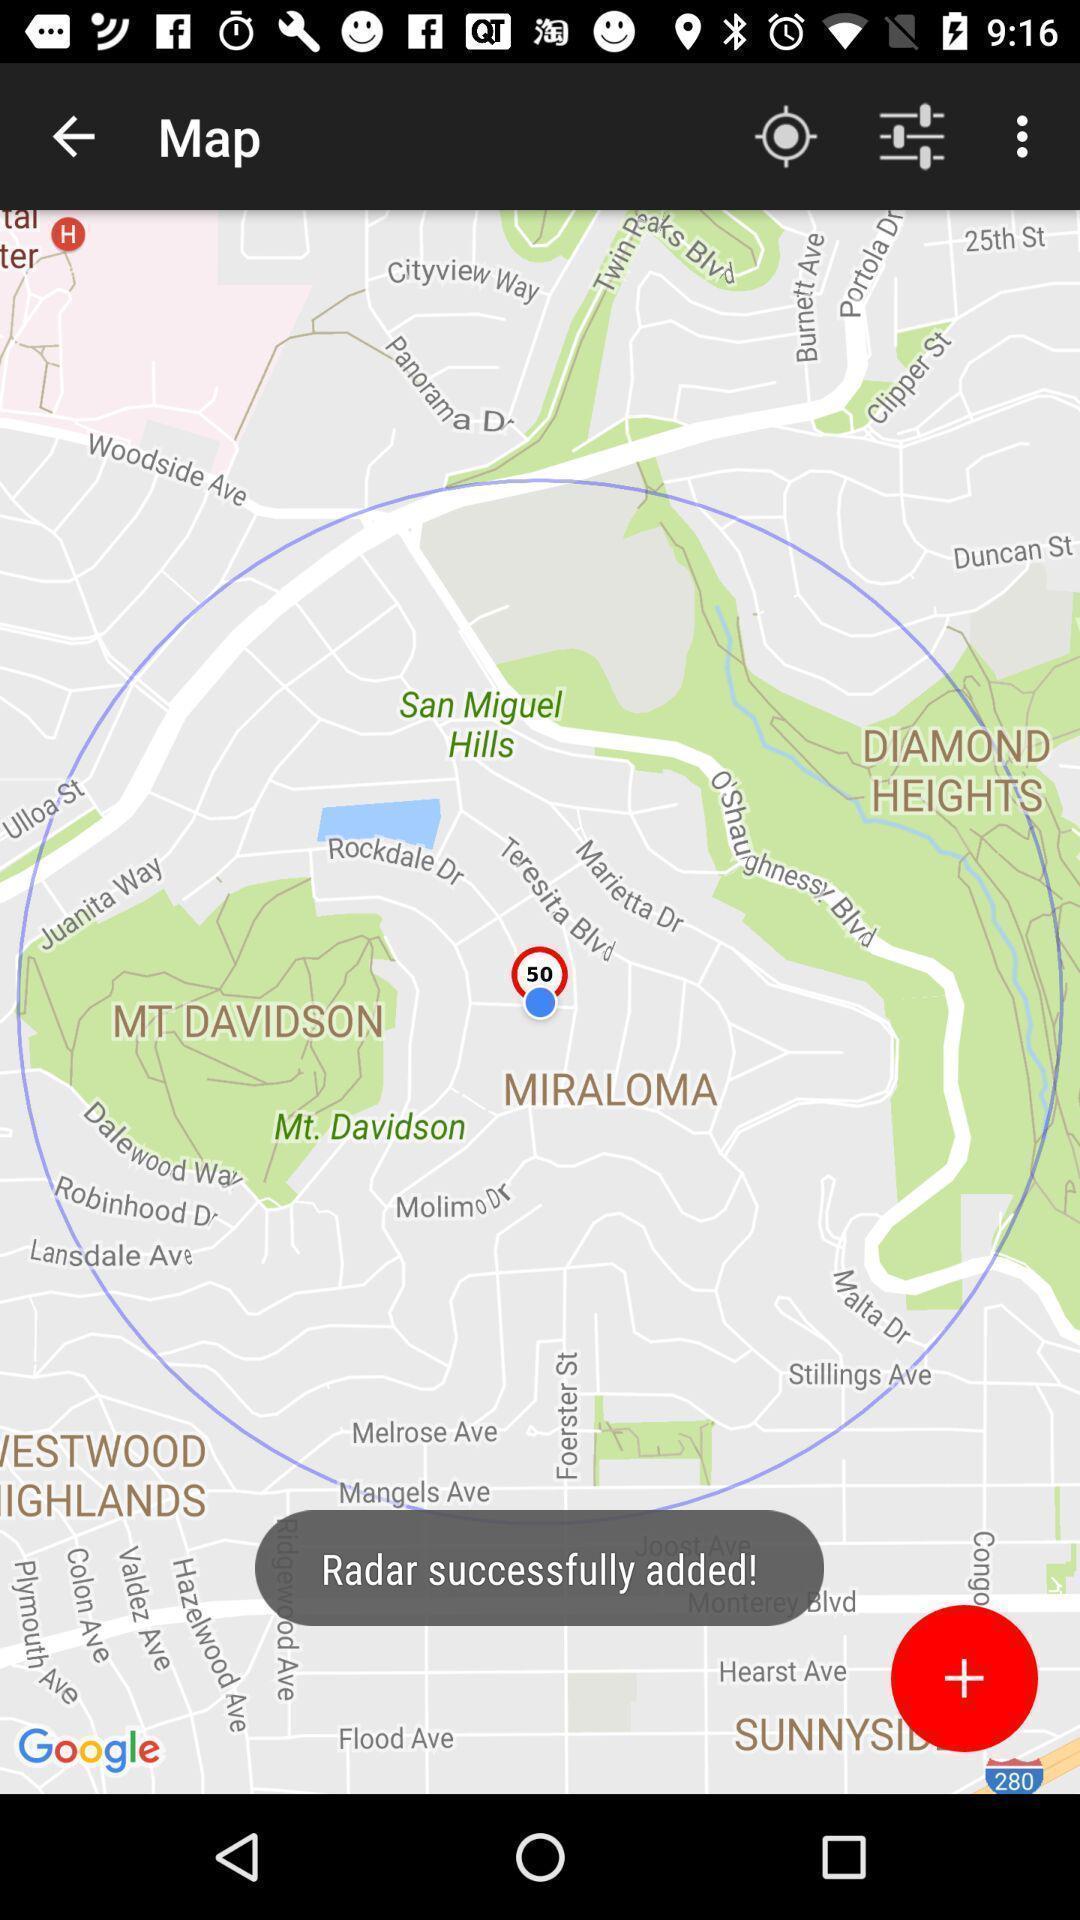Summarize the main components in this picture. Page of a map application with a settings option. 